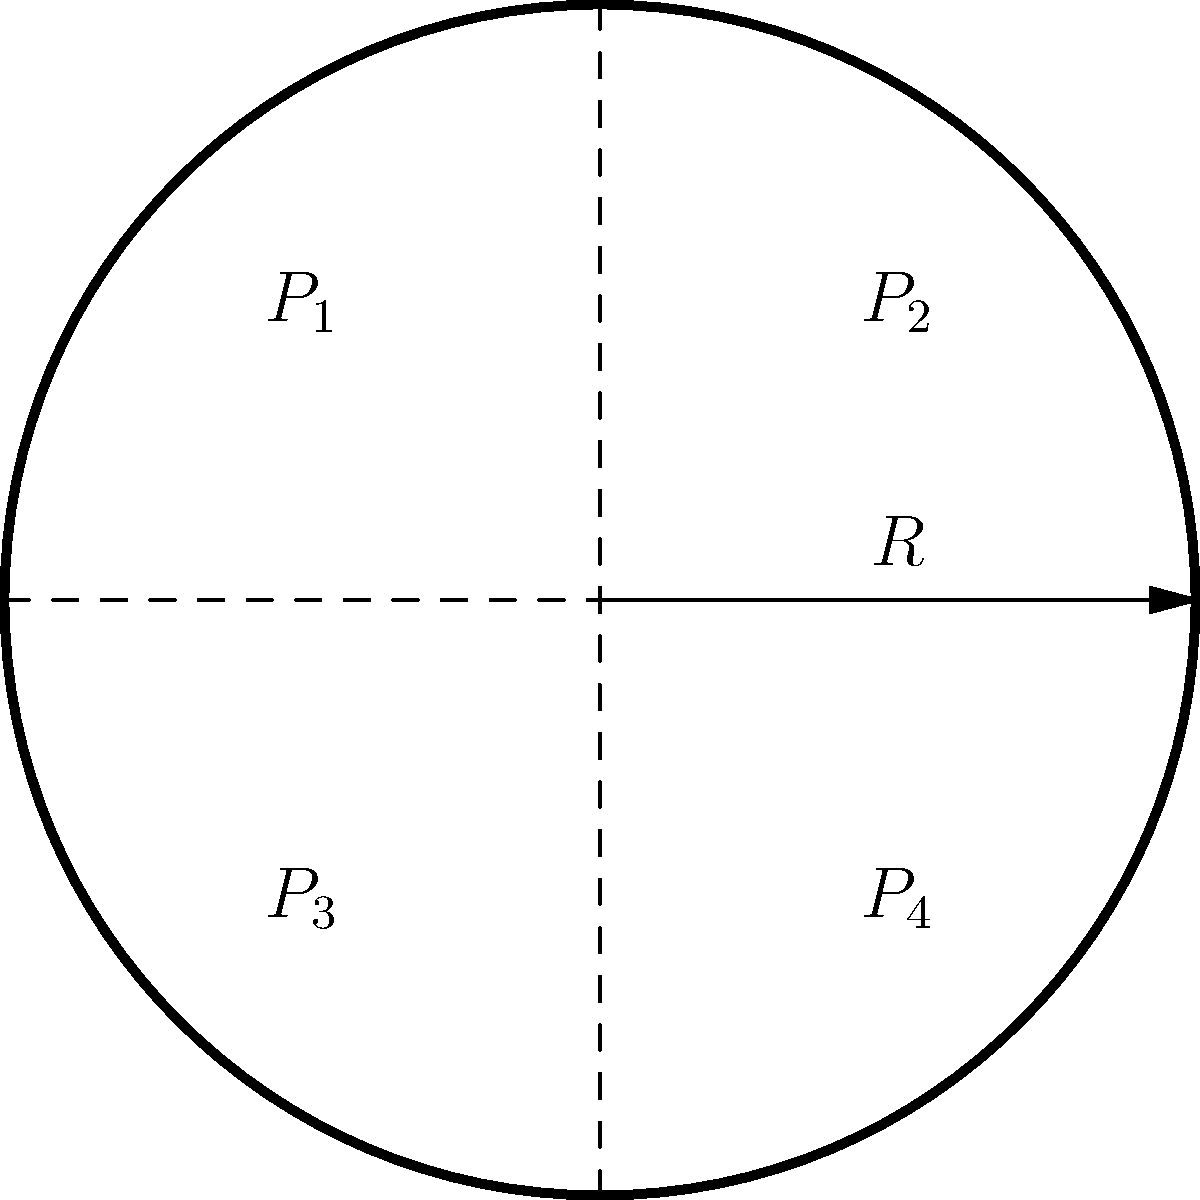A cylindrical space station module with radius $R$ is divided into four compartments, each maintained at different internal pressures $P_1$, $P_2$, $P_3$, and $P_4$ as shown in the diagram. The external pressure is negligible. If the maximum allowable hoop stress in the module's wall is $\sigma_{max}$, what is the minimum required wall thickness $t$ in terms of $R$, $\sigma_{max}$, and the maximum pressure difference $\Delta P_{max}$ between any two adjacent compartments? To determine the minimum required wall thickness, we need to follow these steps:

1) The hoop stress in a thin-walled cylinder is given by the formula:

   $$\sigma = \frac{PR}{t}$$

   where $\sigma$ is the hoop stress, $P$ is the pressure difference, $R$ is the radius, and $t$ is the wall thickness.

2) In this case, we're concerned with the maximum pressure difference between adjacent compartments, $\Delta P_{max}$, as this will create the highest stress.

3) We want the maximum stress to be equal to the allowable stress $\sigma_{max}$:

   $$\sigma_{max} = \frac{\Delta P_{max} R}{t}$$

4) Rearranging this equation to solve for $t$:

   $$t = \frac{\Delta P_{max} R}{\sigma_{max}}$$

This gives us the minimum required wall thickness to withstand the maximum pressure difference between any two adjacent compartments.
Answer: $t = \frac{\Delta P_{max} R}{\sigma_{max}}$ 